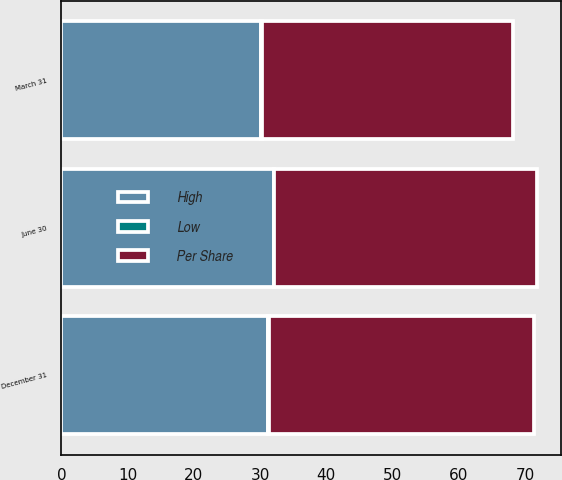Convert chart. <chart><loc_0><loc_0><loc_500><loc_500><stacked_bar_chart><ecel><fcel>June 30<fcel>March 31<fcel>December 31<nl><fcel>Per Share<fcel>39.65<fcel>37.84<fcel>40<nl><fcel>High<fcel>32.05<fcel>30.2<fcel>31.2<nl><fcel>Low<fcel>0.12<fcel>0.12<fcel>0.1<nl></chart> 